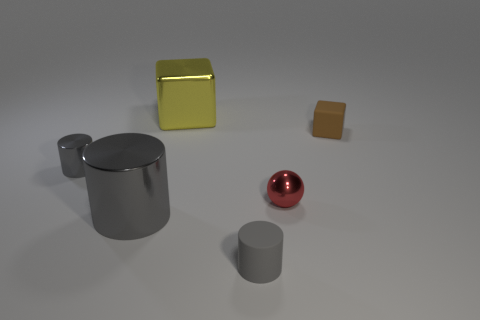Subtract all small gray rubber cylinders. How many cylinders are left? 2 Add 2 large gray metallic cylinders. How many objects exist? 8 Subtract all brown blocks. How many blocks are left? 1 Subtract all balls. How many objects are left? 5 Subtract all purple balls. How many cyan blocks are left? 0 Subtract all gray metallic things. Subtract all brown matte objects. How many objects are left? 3 Add 3 gray metallic objects. How many gray metallic objects are left? 5 Add 2 small matte things. How many small matte things exist? 4 Subtract 0 brown spheres. How many objects are left? 6 Subtract 1 blocks. How many blocks are left? 1 